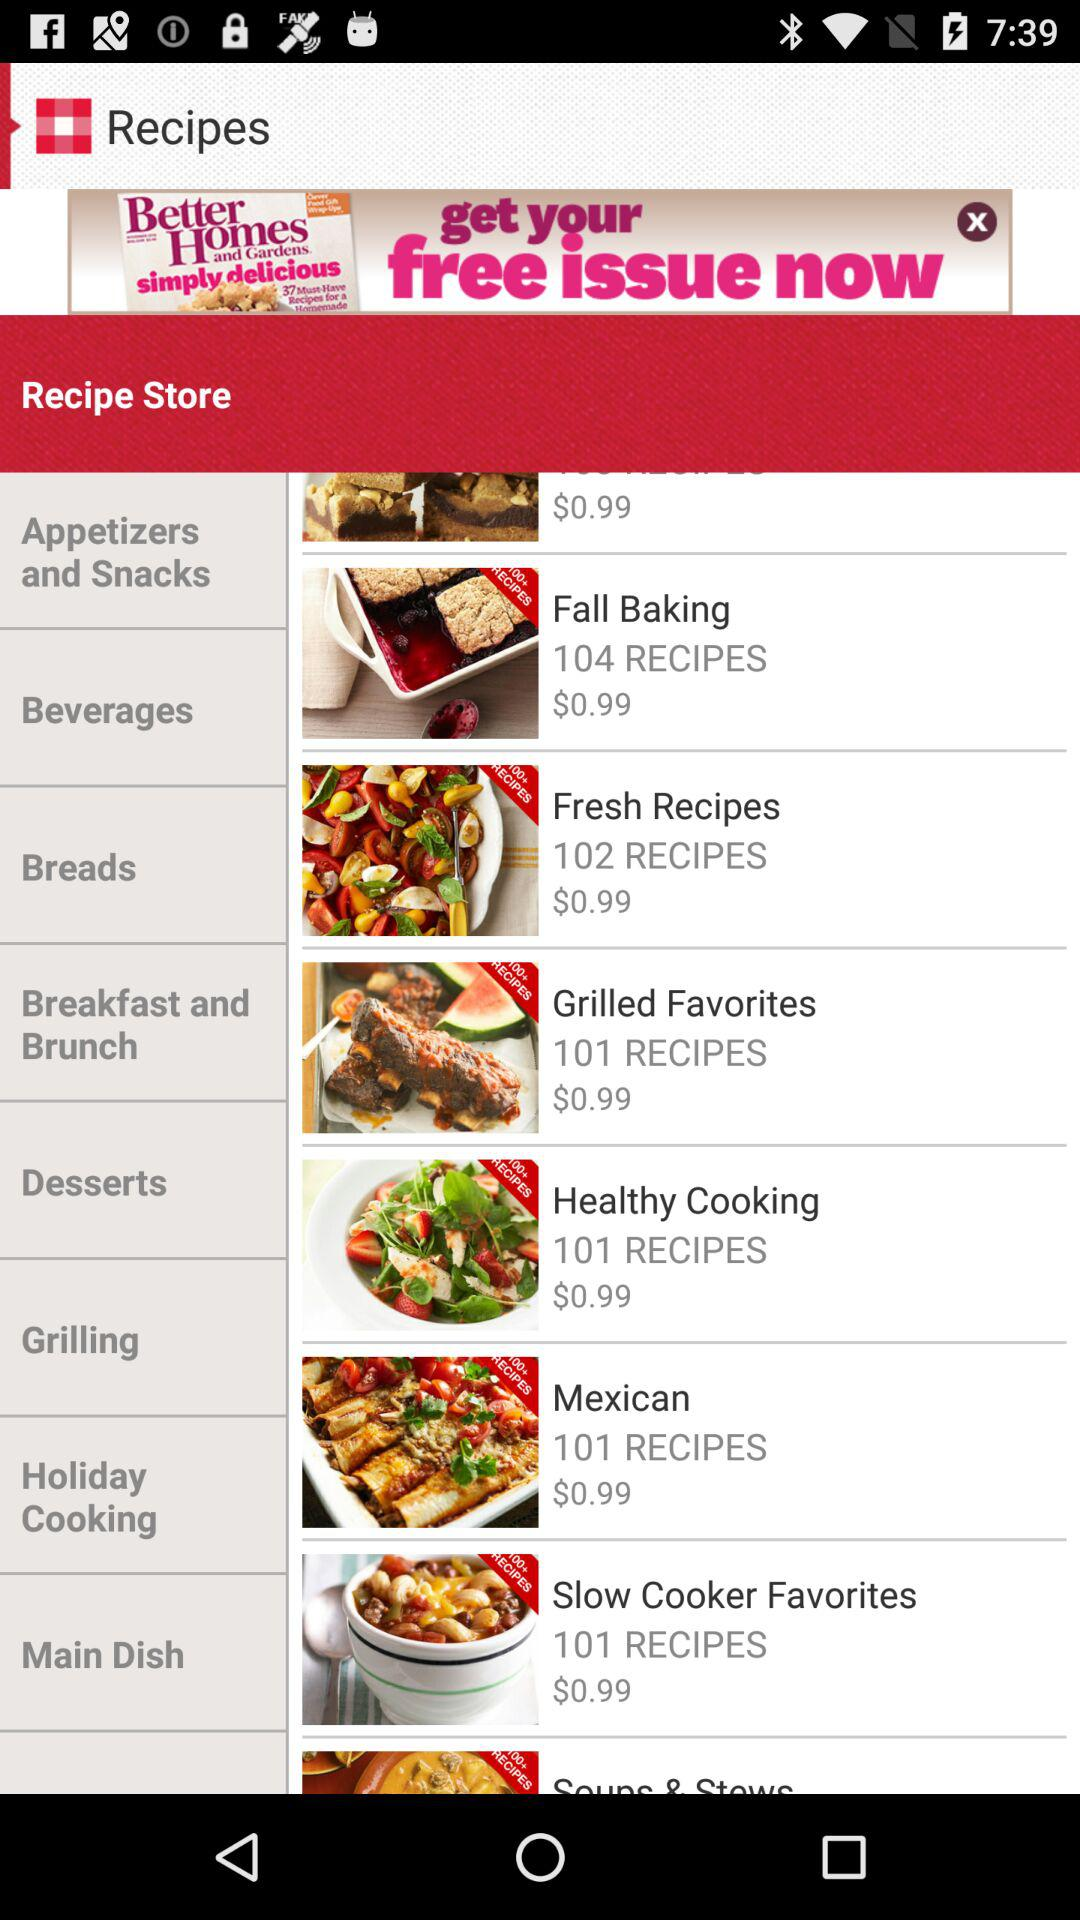How many recipes are in the Mexican section?
Answer the question using a single word or phrase. 101 